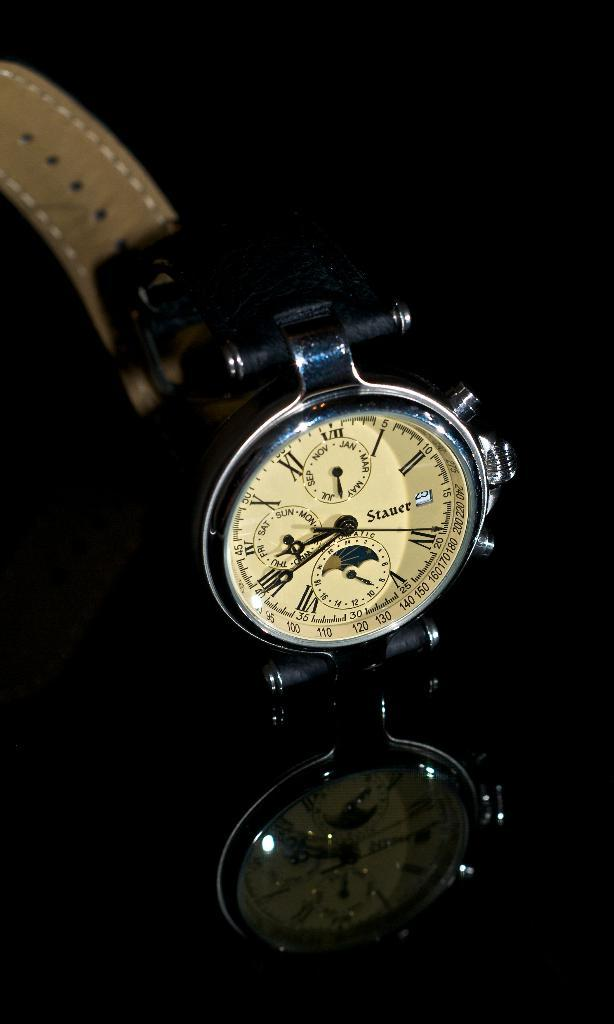<image>
Present a compact description of the photo's key features. Face of a watch which says "STAUER" on it. 